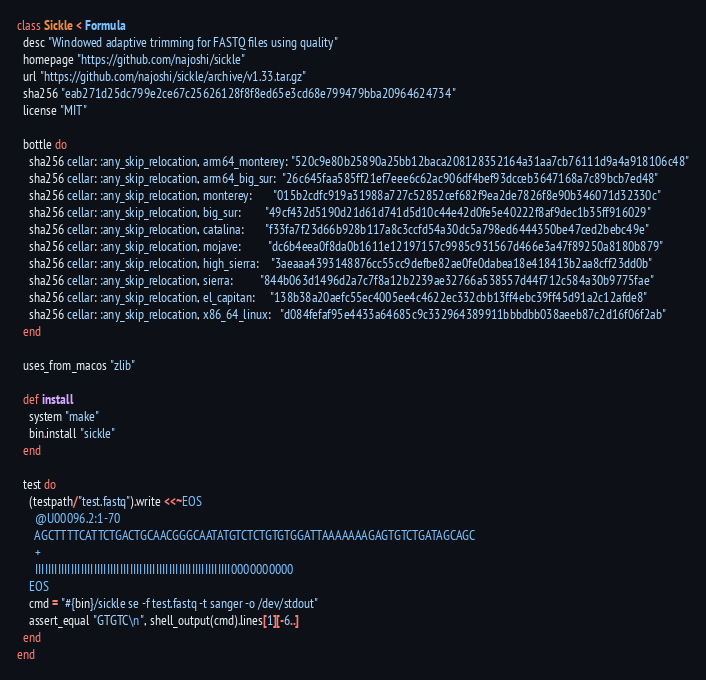Convert code to text. <code><loc_0><loc_0><loc_500><loc_500><_Ruby_>class Sickle < Formula
  desc "Windowed adaptive trimming for FASTQ files using quality"
  homepage "https://github.com/najoshi/sickle"
  url "https://github.com/najoshi/sickle/archive/v1.33.tar.gz"
  sha256 "eab271d25dc799e2ce67c25626128f8f8ed65e3cd68e799479bba20964624734"
  license "MIT"

  bottle do
    sha256 cellar: :any_skip_relocation, arm64_monterey: "520c9e80b25890a25bb12baca208128352164a31aa7cb76111d9a4a918106c48"
    sha256 cellar: :any_skip_relocation, arm64_big_sur:  "26c645faa585ff21ef7eee6c62ac906df4bef93dcceb3647168a7c89bcb7ed48"
    sha256 cellar: :any_skip_relocation, monterey:       "015b2cdfc919a31988a727c52852cef682f9ea2de7826f8e90b346071d32330c"
    sha256 cellar: :any_skip_relocation, big_sur:        "49cf432d5190d21d61d741d5d10c44e42d0fe5e40222f8af9dec1b35ff916029"
    sha256 cellar: :any_skip_relocation, catalina:       "f33fa7f23d66b928b117a8c3ccfd54a30dc5a798ed6444350be47ced2bebc49e"
    sha256 cellar: :any_skip_relocation, mojave:         "dc6b4eea0f8da0b1611e12197157c9985c931567d466e3a47f89250a8180b879"
    sha256 cellar: :any_skip_relocation, high_sierra:    "3aeaaa4393148876cc55cc9defbe82ae0fe0dabea18e418413b2aa8cff23dd0b"
    sha256 cellar: :any_skip_relocation, sierra:         "844b063d1496d2a7c7f8a12b2239ae32766a538557d44f712c584a30b9775fae"
    sha256 cellar: :any_skip_relocation, el_capitan:     "138b38a20aefc55ec4005ee4c4622ec332cbb13ff4ebc39ff45d91a2c12afde8"
    sha256 cellar: :any_skip_relocation, x86_64_linux:   "d084fefaf95e4433a64685c9c332964389911bbbdbb038aeeb87c2d16f06f2ab"
  end

  uses_from_macos "zlib"

  def install
    system "make"
    bin.install "sickle"
  end

  test do
    (testpath/"test.fastq").write <<~EOS
      @U00096.2:1-70
      AGCTTTTCATTCTGACTGCAACGGGCAATATGTCTCTGTGTGGATTAAAAAAAGAGTGTCTGATAGCAGC
      +
      IIIIIIIIIIIIIIIIIIIIIIIIIIIIIIIIIIIIIIIIIIIIIIIIIIIIIIIIIIII0000000000
    EOS
    cmd = "#{bin}/sickle se -f test.fastq -t sanger -o /dev/stdout"
    assert_equal "GTGTC\n", shell_output(cmd).lines[1][-6..]
  end
end
</code> 